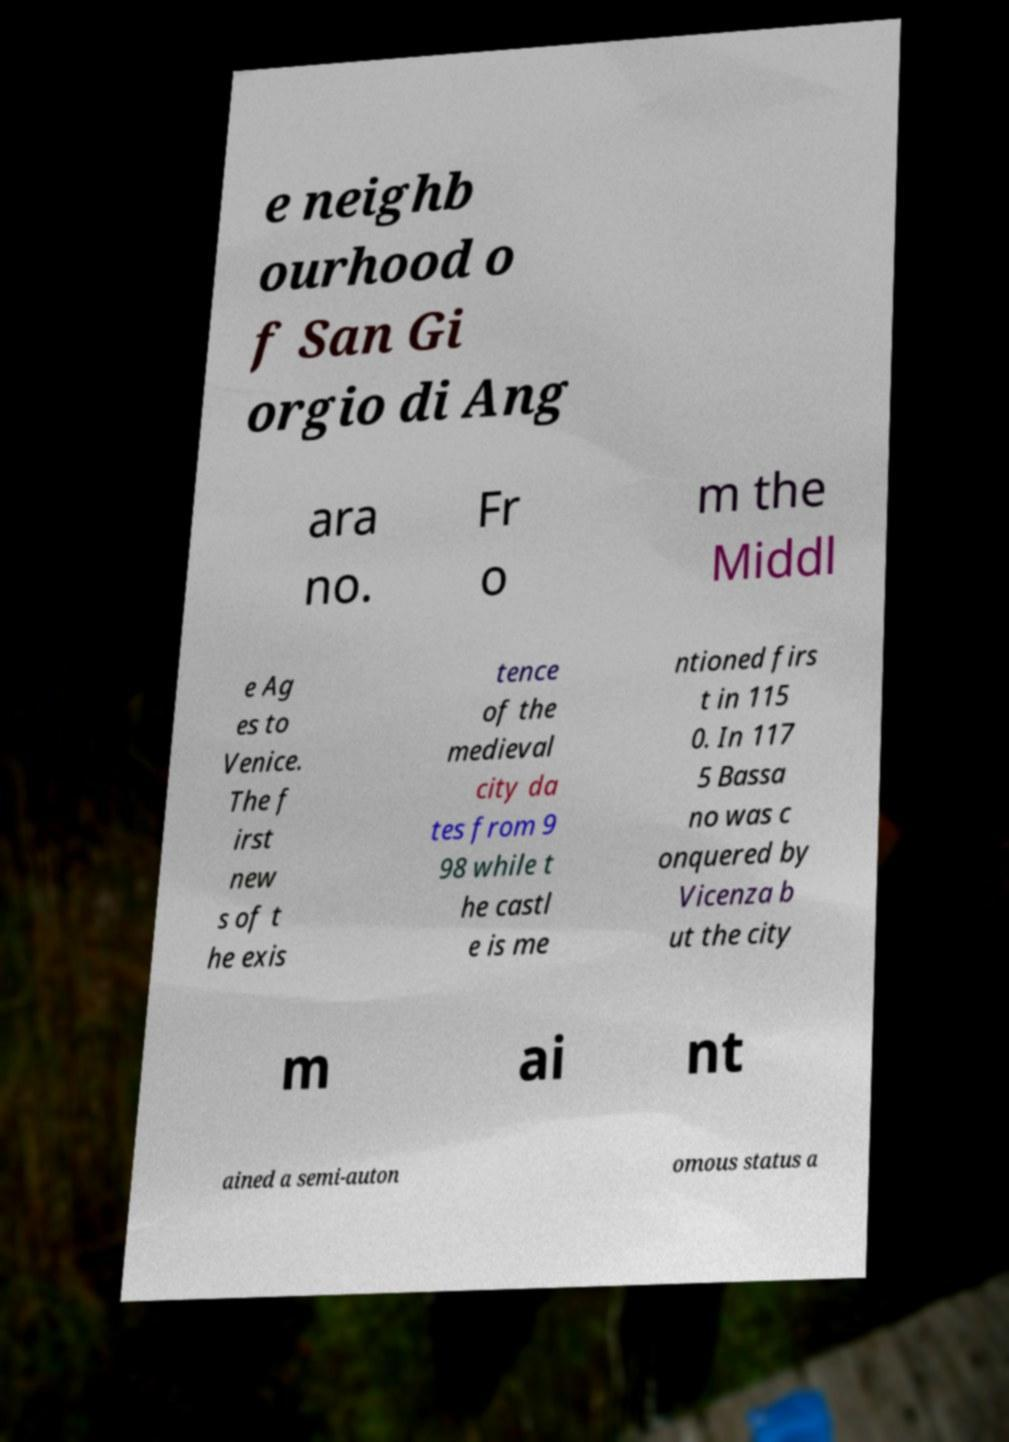I need the written content from this picture converted into text. Can you do that? e neighb ourhood o f San Gi orgio di Ang ara no. Fr o m the Middl e Ag es to Venice. The f irst new s of t he exis tence of the medieval city da tes from 9 98 while t he castl e is me ntioned firs t in 115 0. In 117 5 Bassa no was c onquered by Vicenza b ut the city m ai nt ained a semi-auton omous status a 